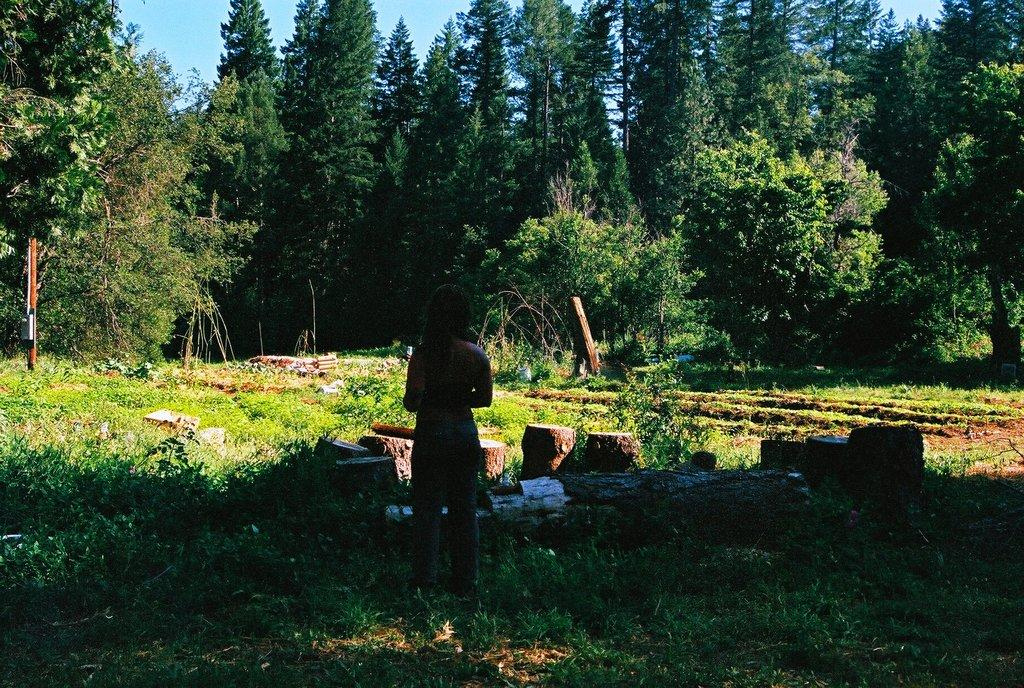What is the main subject of the image? There is a person standing in the image. What is the person standing on? The person is standing on grass. What can be seen in front of the person? Tree trunks are visible in front of the person. What is visible in the background of the image? There are many trees and a blue sky in the background of the image. What type of flesh can be seen hanging from the trees in the image? There is no flesh hanging from the trees in the image; it features a person standing on grass with tree trunks in front of them and many trees in the background. 